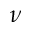Convert formula to latex. <formula><loc_0><loc_0><loc_500><loc_500>\nu</formula> 